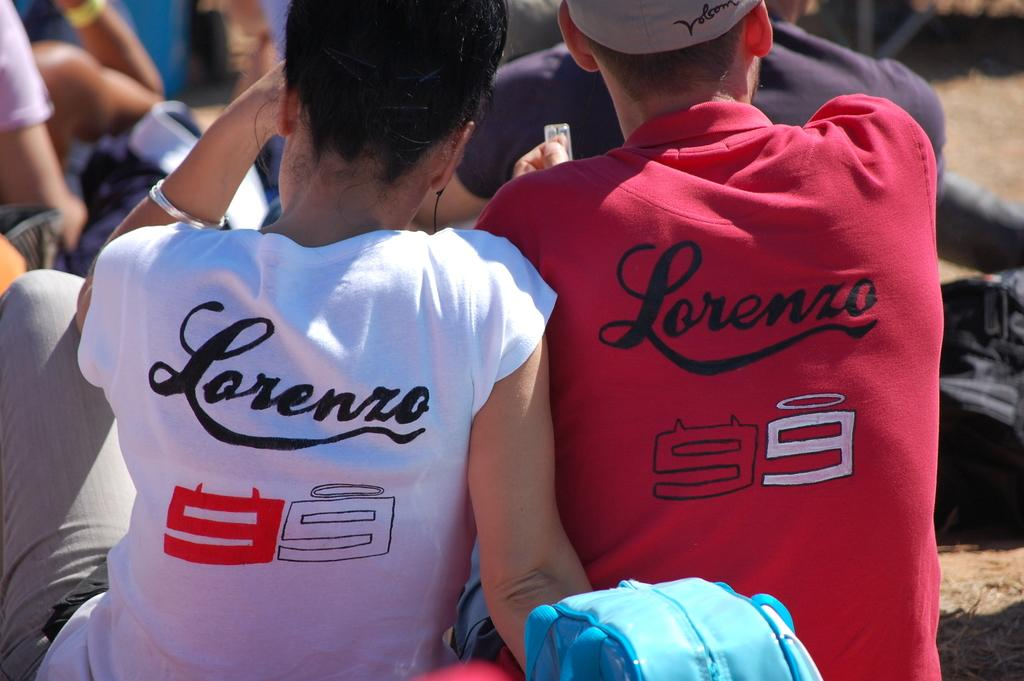<image>
Provide a brief description of the given image. Two people are sitting down on the lawn with matching tee shirts that says Lorenzo on the back. 